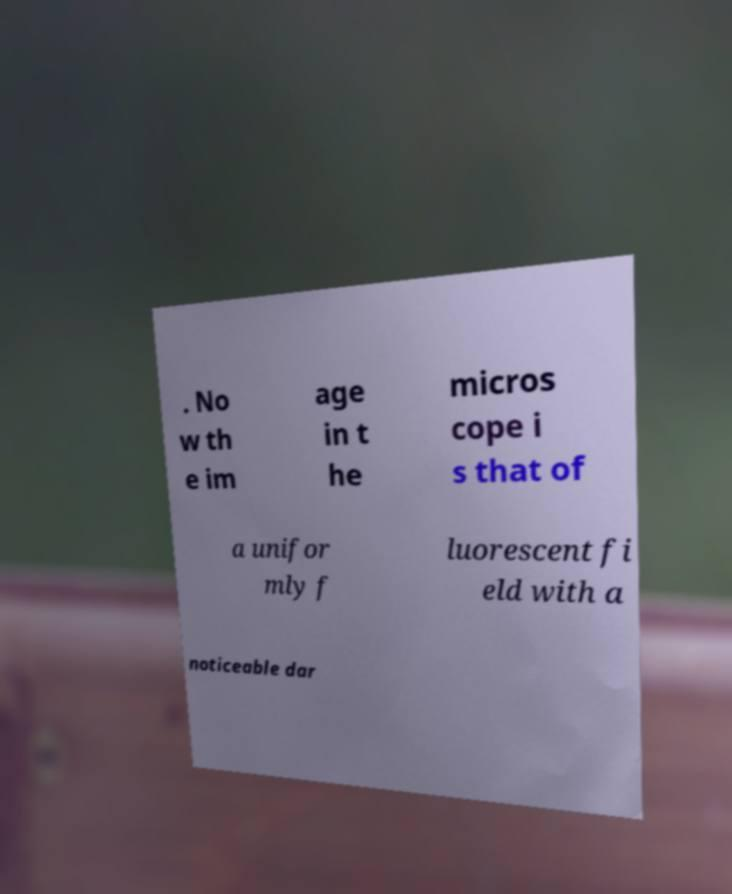For documentation purposes, I need the text within this image transcribed. Could you provide that? . No w th e im age in t he micros cope i s that of a unifor mly f luorescent fi eld with a noticeable dar 